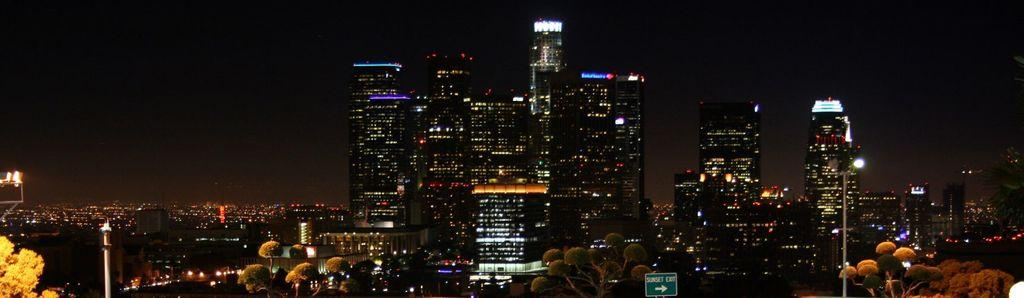What type of view is depicted in the image? The image has an outside view. What structures can be seen in the foreground of the image? There are buildings in the foreground of the image. What type of vegetation is present at the bottom of the image? There are trees at the bottom of the image. What is visible in the background of the image? The sky is visible in the background of the image. What color is the glue used to attach the growth to the buildings in the image? There is no glue or growth present in the image; it features an outside view with buildings and trees. 